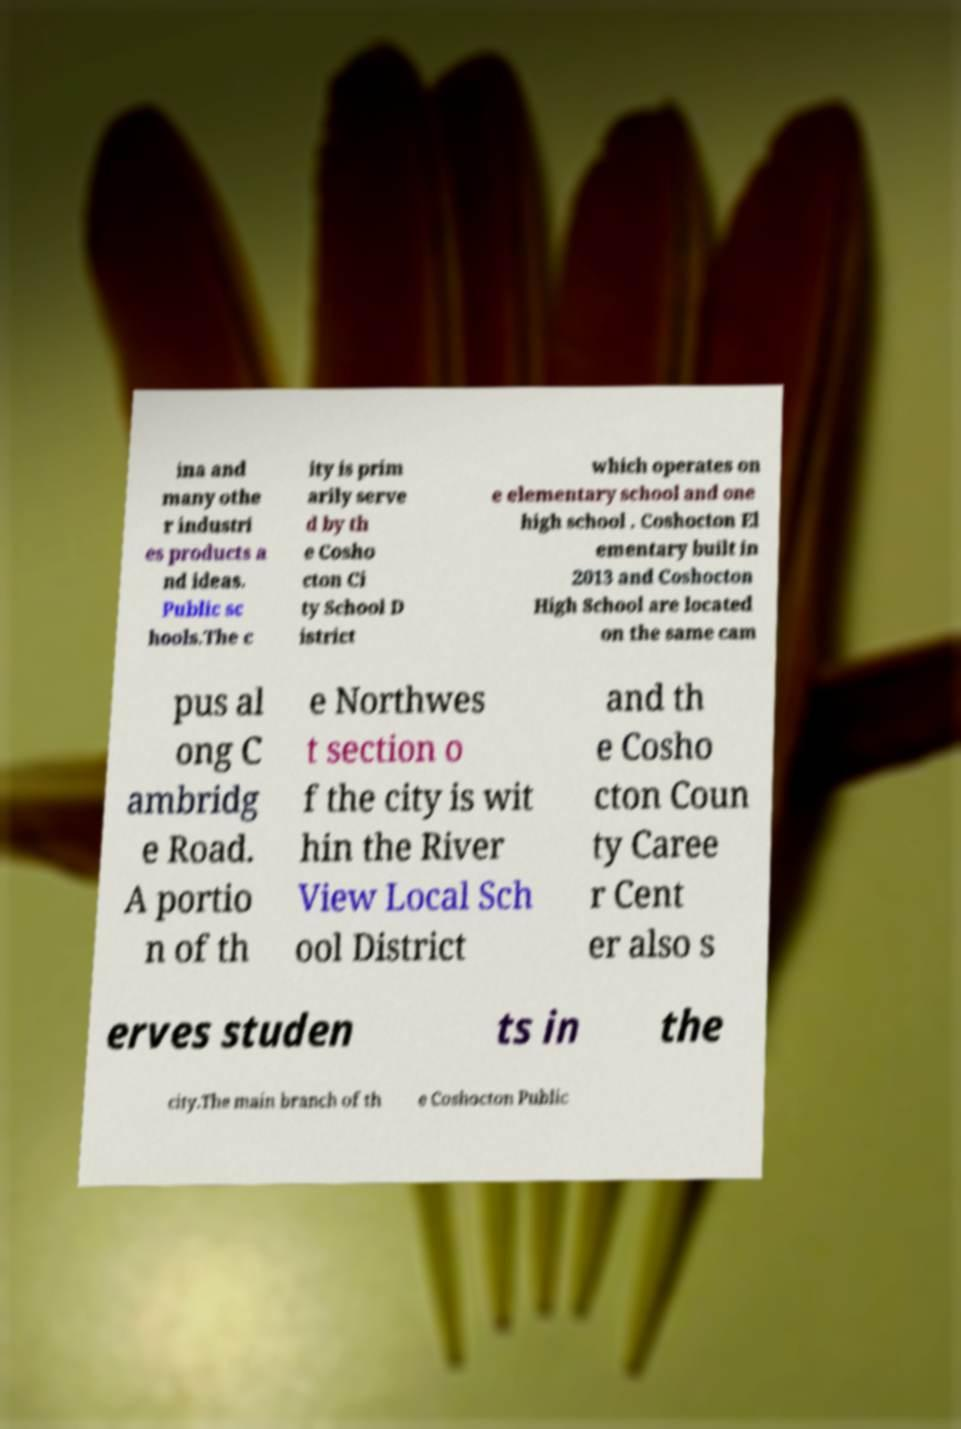Can you accurately transcribe the text from the provided image for me? ina and many othe r industri es products a nd ideas. Public sc hools.The c ity is prim arily serve d by th e Cosho cton Ci ty School D istrict which operates on e elementary school and one high school . Coshocton El ementary built in 2013 and Coshocton High School are located on the same cam pus al ong C ambridg e Road. A portio n of th e Northwes t section o f the city is wit hin the River View Local Sch ool District and th e Cosho cton Coun ty Caree r Cent er also s erves studen ts in the city.The main branch of th e Coshocton Public 